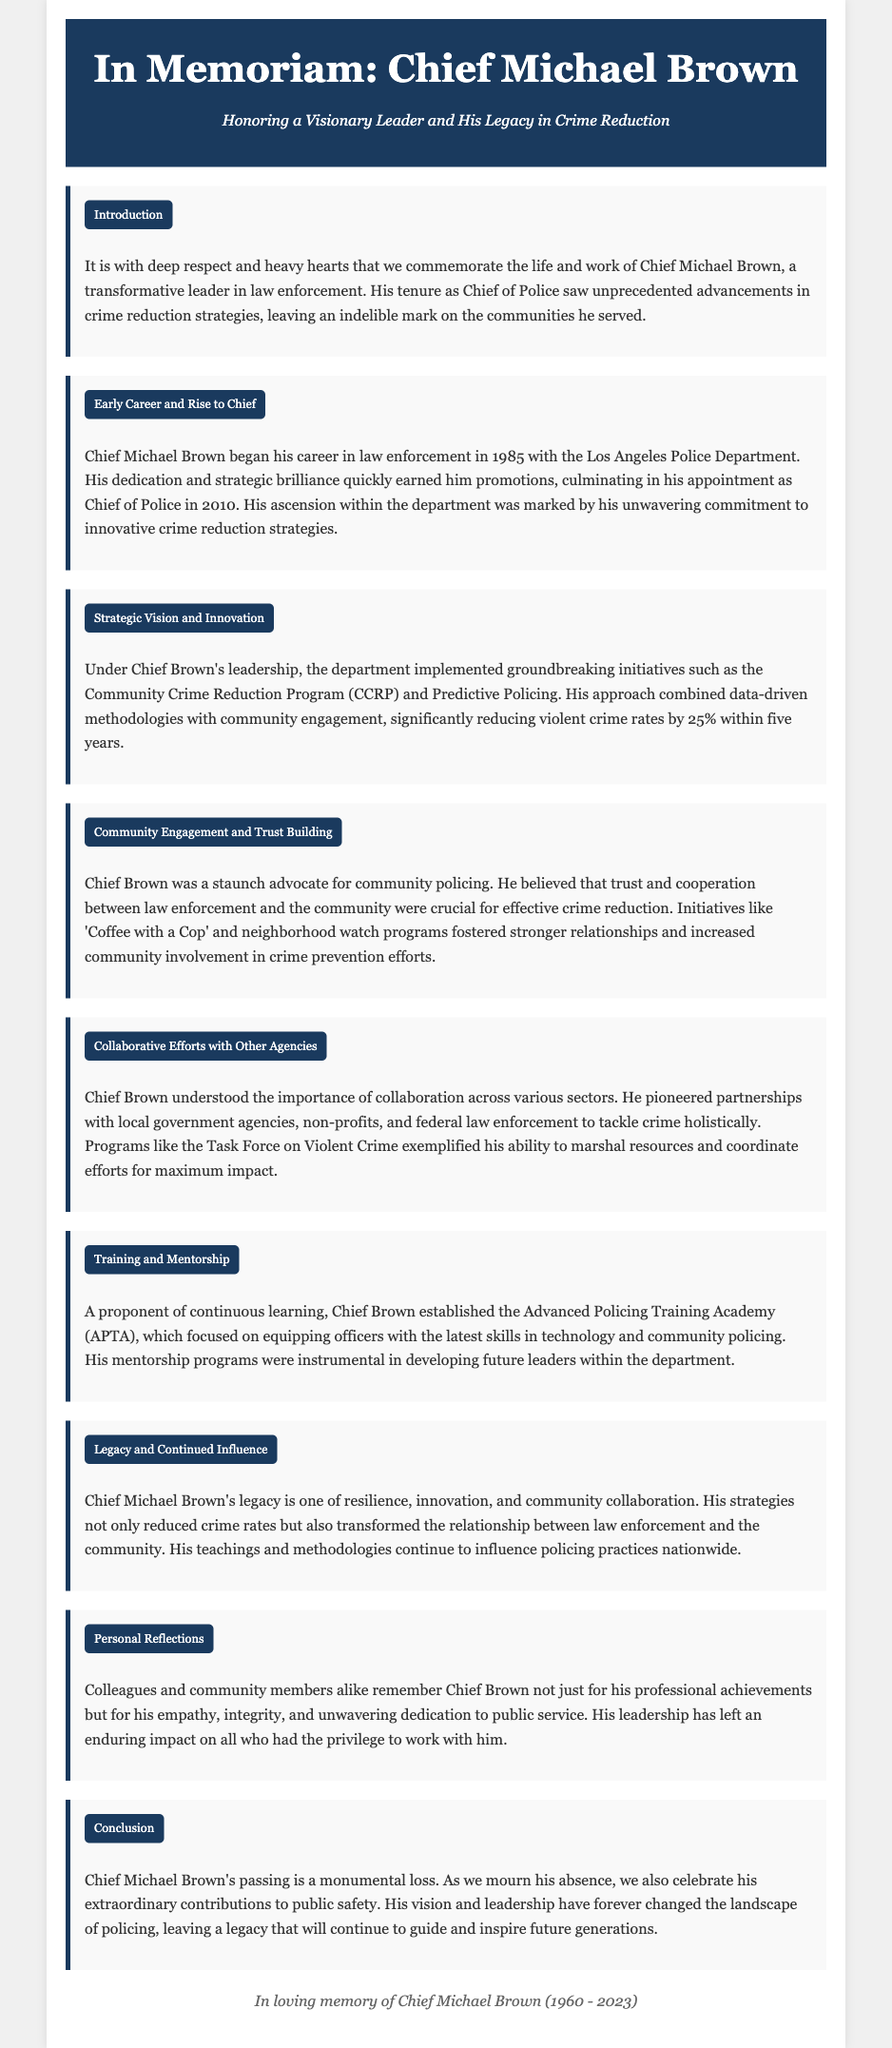what year did Chief Michael Brown start his law enforcement career? Chief Michael Brown began his career in law enforcement in 1985, as indicated in the document.
Answer: 1985 what program did Chief Brown implement to engage the community? The document mentions 'Coffee with a Cop' as one of the initiatives to foster community engagement.
Answer: 'Coffee with a Cop' what was the percentage reduction in violent crime under Chief Brown's leadership? The document states that violent crime rates were significantly reduced by 25% within five years of his initiatives.
Answer: 25% what year was Chief Michael Brown appointed as Chief of Police? His appointment as Chief of Police took place in 2010, as stated in the document.
Answer: 2010 what is the name of the training academy established by Chief Brown? The document refers to the Advanced Policing Training Academy (APTA) as the training program he established.
Answer: Advanced Policing Training Academy (APTA) how is Chief Brown remembered by colleagues and community members? The document highlights that he is remembered for his empathy, integrity, and unwavering dedication to public service.
Answer: empathy, integrity, and unwavering dedication what key partnership strategy did Chief Brown pioneer? Chief Brown pioneered partnerships with local government agencies, non-profits, and federal law enforcement to tackle crime holistically, as mentioned in the document.
Answer: partnerships with local government agencies, non-profits, and federal law enforcement what was Chief Brown's approach to crime reduction? His approach combined data-driven methodologies with community engagement as outlined in the document.
Answer: data-driven methodologies with community engagement 